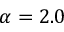<formula> <loc_0><loc_0><loc_500><loc_500>\alpha = 2 . 0</formula> 